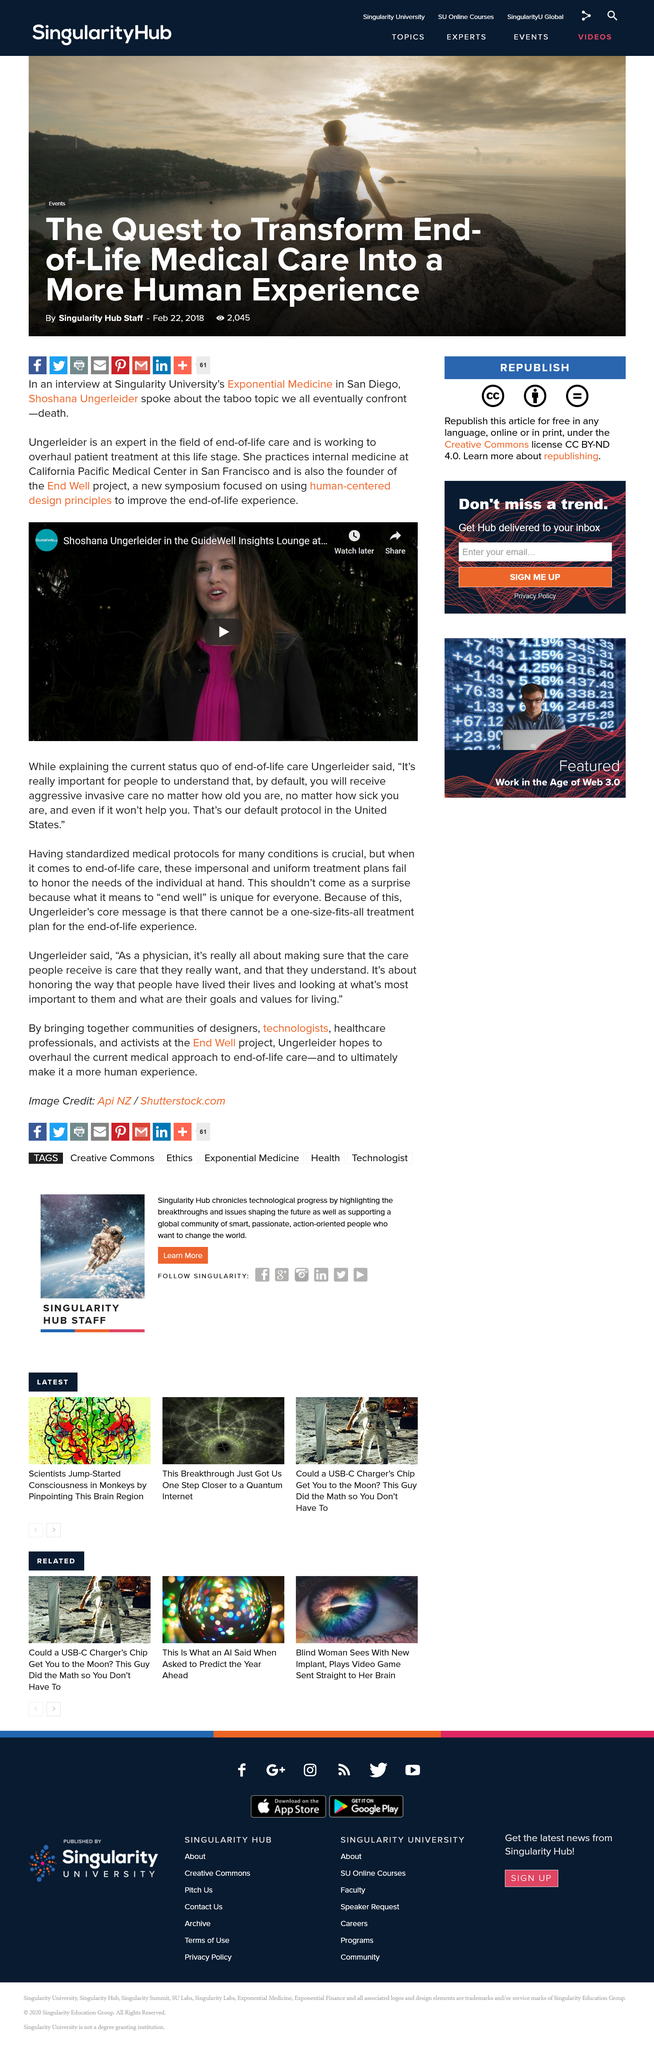Draw attention to some important aspects in this diagram. Shoshana Ungerleider is the founder of the End Well project, which is a notable endeavor in its field. Shoshana Ungerleider practices internal medicine at California Pacific Medical Center in San Francisco. Shoshana Ungerleider is an expert in the field of end-of-life care. 